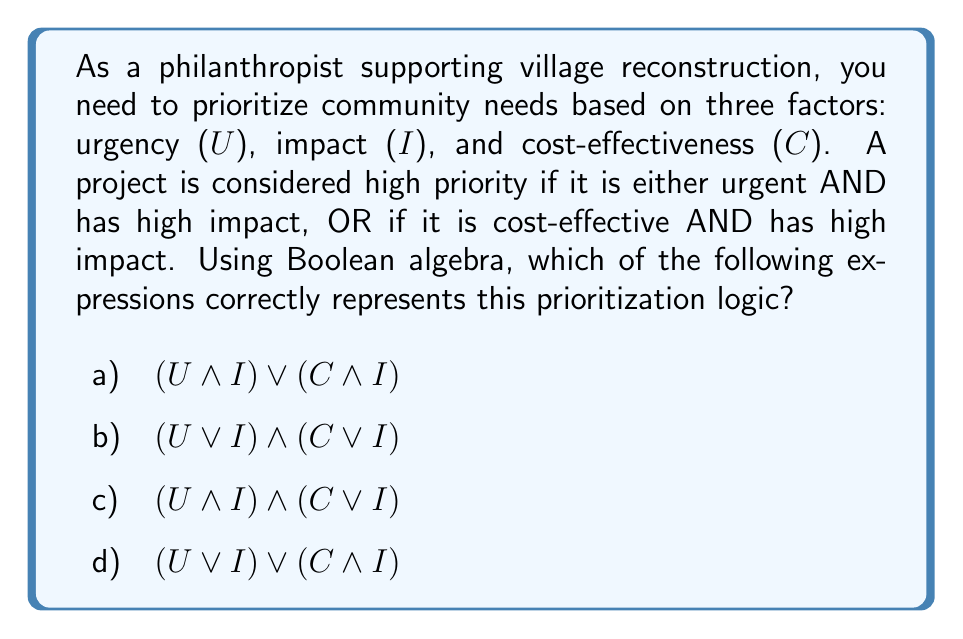Give your solution to this math problem. Let's break down the prioritization logic step-by-step:

1) We have three variables:
   U: Urgency
   I: Impact
   C: Cost-effectiveness

2) A project is high priority if it meets either of these conditions:
   - It is urgent AND has high impact
   - It is cost-effective AND has high impact

3) Let's translate each condition into Boolean algebra:
   - Urgent AND high impact: $U \land I$
   - Cost-effective AND high impact: $C \land I$

4) Since a project needs to meet either of these conditions, we connect them with an OR operator:

   $$(U \land I) \lor (C \land I)$$

5) This expression matches option a) in the question.

6) Let's verify why the other options are incorrect:
   b) $$(U \lor I) \land (C \lor I)$$ - This would prioritize projects that are either urgent OR high impact, AND either cost-effective OR high impact. This is too broad and doesn't match our criteria.
   c) $$(U \land I) \land (C \lor I)$$ - This would require a project to be urgent AND high impact, while also being either cost-effective OR high impact. This is too restrictive.
   d) $$(U \lor I) \lor (C \land I)$$ - This would prioritize any project that is either urgent OR high impact, OR (cost-effective AND high impact). This is too broad as it would include non-impactful urgent projects.

Therefore, the correct expression is option a) $$(U \land I) \lor (C \land I)$$.
Answer: a) $$(U \land I) \lor (C \land I)$$ 